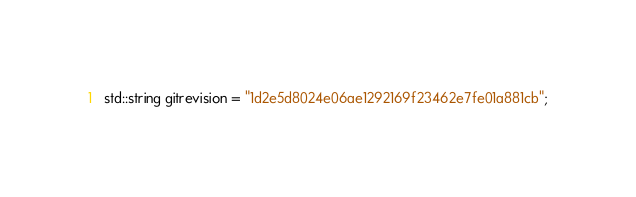Convert code to text. <code><loc_0><loc_0><loc_500><loc_500><_C_>std::string gitrevision = "1d2e5d8024e06ae1292169f23462e7fe01a881cb";</code> 